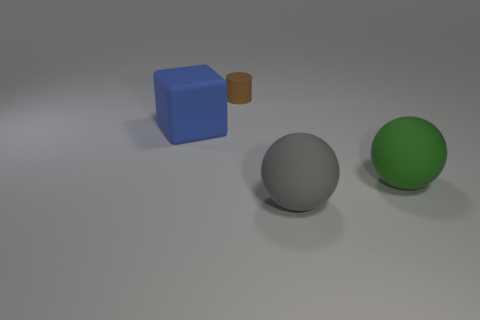What is the size of the blue block that is made of the same material as the tiny brown thing?
Keep it short and to the point. Large. How many small brown objects are the same shape as the blue rubber thing?
Ensure brevity in your answer.  0. How many objects are either things right of the blue matte block or big matte objects that are to the left of the small brown cylinder?
Ensure brevity in your answer.  4. What number of blue rubber cubes are left of the matte object on the left side of the small thing?
Give a very brief answer. 0. Do the big thing that is on the left side of the small brown cylinder and the large matte thing right of the gray ball have the same shape?
Ensure brevity in your answer.  No. Are there any other cubes made of the same material as the blue cube?
Make the answer very short. No. How many metallic things are small brown cylinders or large blue cylinders?
Give a very brief answer. 0. The rubber object behind the matte thing that is left of the small object is what shape?
Make the answer very short. Cylinder. Are there fewer small brown cylinders behind the big blue matte block than green things?
Your answer should be very brief. No. What is the shape of the small brown object?
Give a very brief answer. Cylinder. 